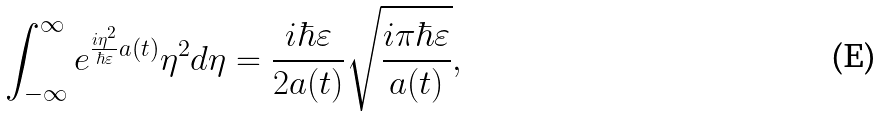<formula> <loc_0><loc_0><loc_500><loc_500>\int ^ { \infty } _ { - \infty } e ^ { \frac { i \eta ^ { 2 } } { \hbar { \varepsilon } } a ( t ) } \eta ^ { 2 } d \eta = \frac { i \hbar { \varepsilon } } { 2 a ( t ) } \sqrt { \frac { i \pi \hbar { \varepsilon } } { a ( t ) } } ,</formula> 